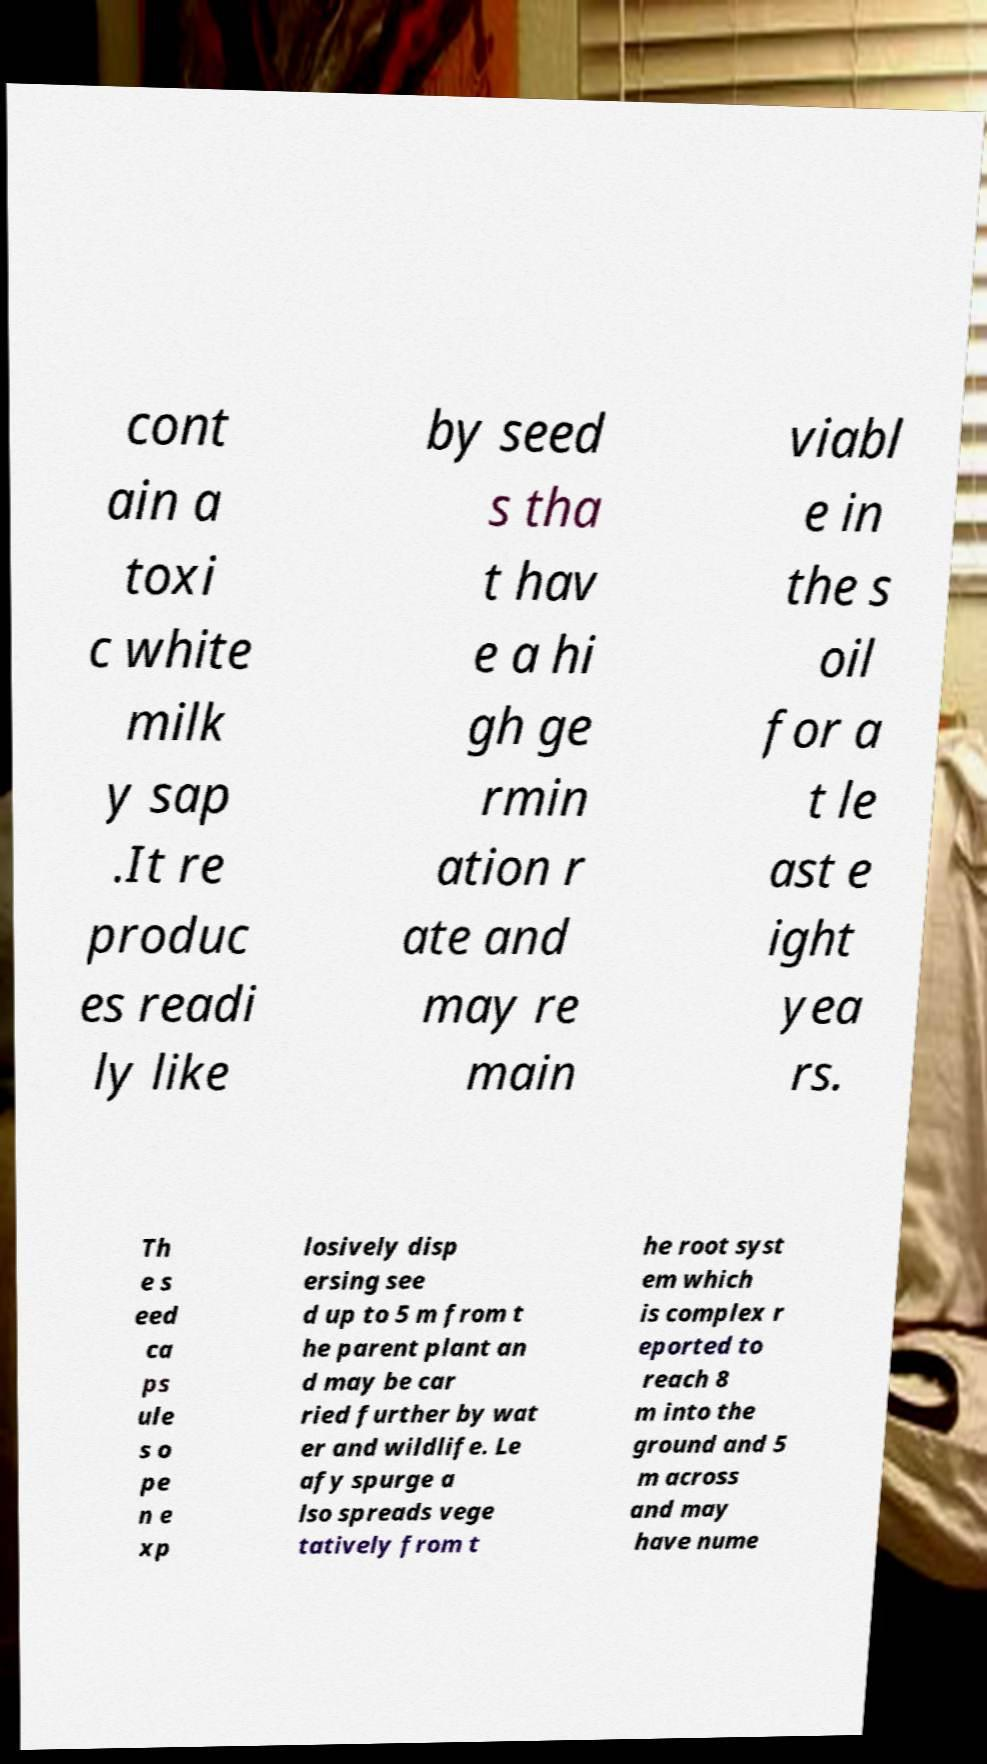There's text embedded in this image that I need extracted. Can you transcribe it verbatim? cont ain a toxi c white milk y sap .It re produc es readi ly like by seed s tha t hav e a hi gh ge rmin ation r ate and may re main viabl e in the s oil for a t le ast e ight yea rs. Th e s eed ca ps ule s o pe n e xp losively disp ersing see d up to 5 m from t he parent plant an d may be car ried further by wat er and wildlife. Le afy spurge a lso spreads vege tatively from t he root syst em which is complex r eported to reach 8 m into the ground and 5 m across and may have nume 